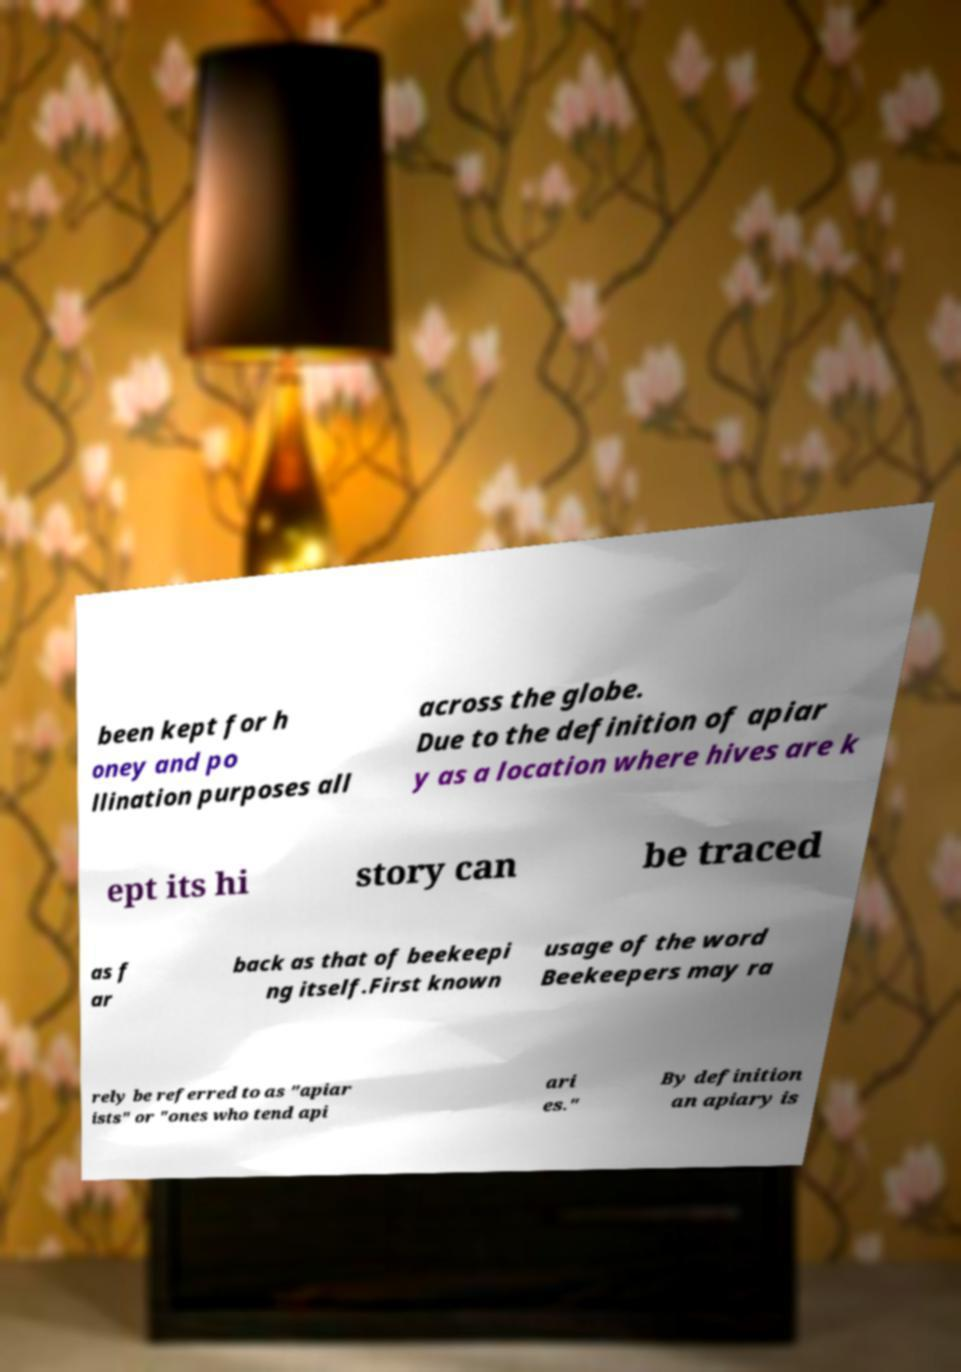For documentation purposes, I need the text within this image transcribed. Could you provide that? been kept for h oney and po llination purposes all across the globe. Due to the definition of apiar y as a location where hives are k ept its hi story can be traced as f ar back as that of beekeepi ng itself.First known usage of the word Beekeepers may ra rely be referred to as "apiar ists" or "ones who tend api ari es." By definition an apiary is 